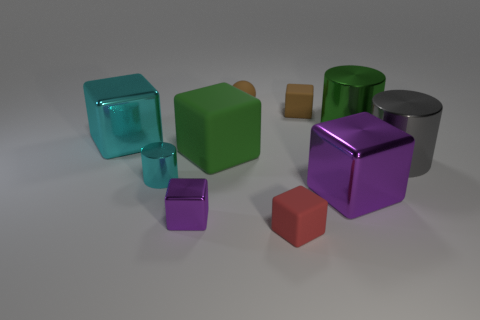Subtract all cyan cubes. How many cubes are left? 5 Subtract all brown blocks. How many blocks are left? 5 Subtract all cyan balls. Subtract all yellow cylinders. How many balls are left? 1 Subtract all cylinders. How many objects are left? 7 Subtract all large green matte objects. Subtract all cyan cylinders. How many objects are left? 8 Add 2 cyan things. How many cyan things are left? 4 Add 3 small red things. How many small red things exist? 4 Subtract 1 cyan cubes. How many objects are left? 9 